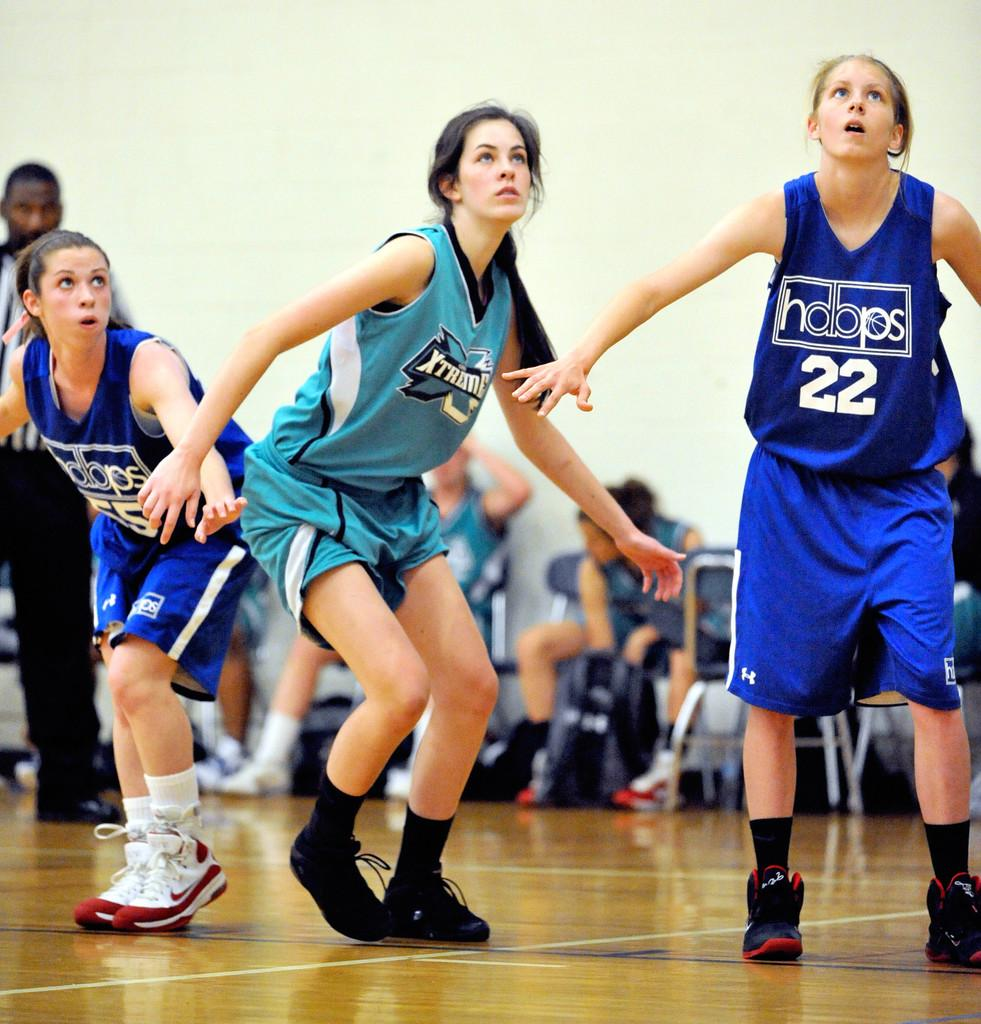<image>
Relay a brief, clear account of the picture shown. An all women's basketball game is underway and one of their jersey's says Xtreme. 